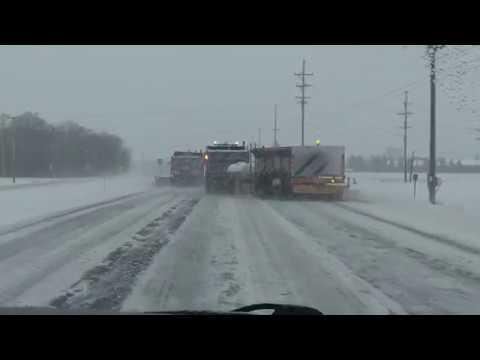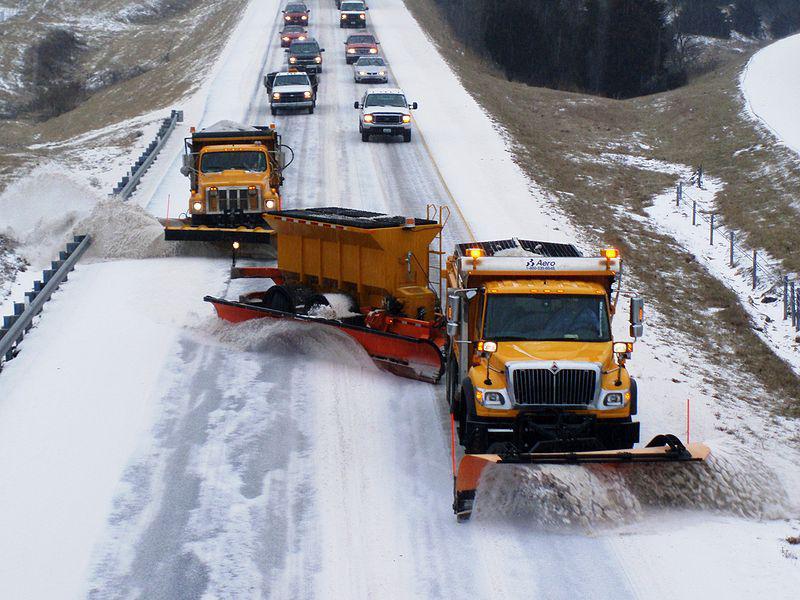The first image is the image on the left, the second image is the image on the right. For the images shown, is this caption "Both images show at least one camera-facing tow plow truck with a yellow cab, clearing a snowy road." true? Answer yes or no. No. 